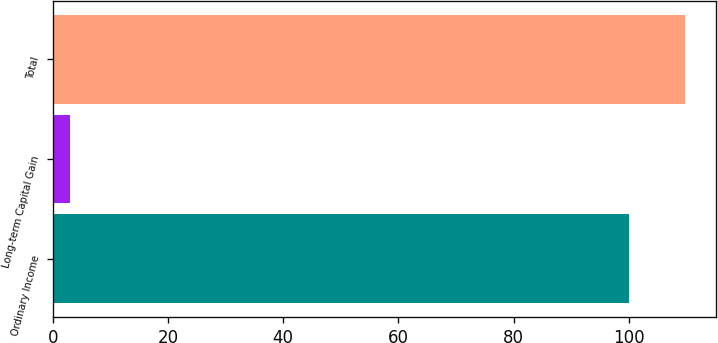<chart> <loc_0><loc_0><loc_500><loc_500><bar_chart><fcel>Ordinary Income<fcel>Long-term Capital Gain<fcel>Total<nl><fcel>100<fcel>3<fcel>109.7<nl></chart> 